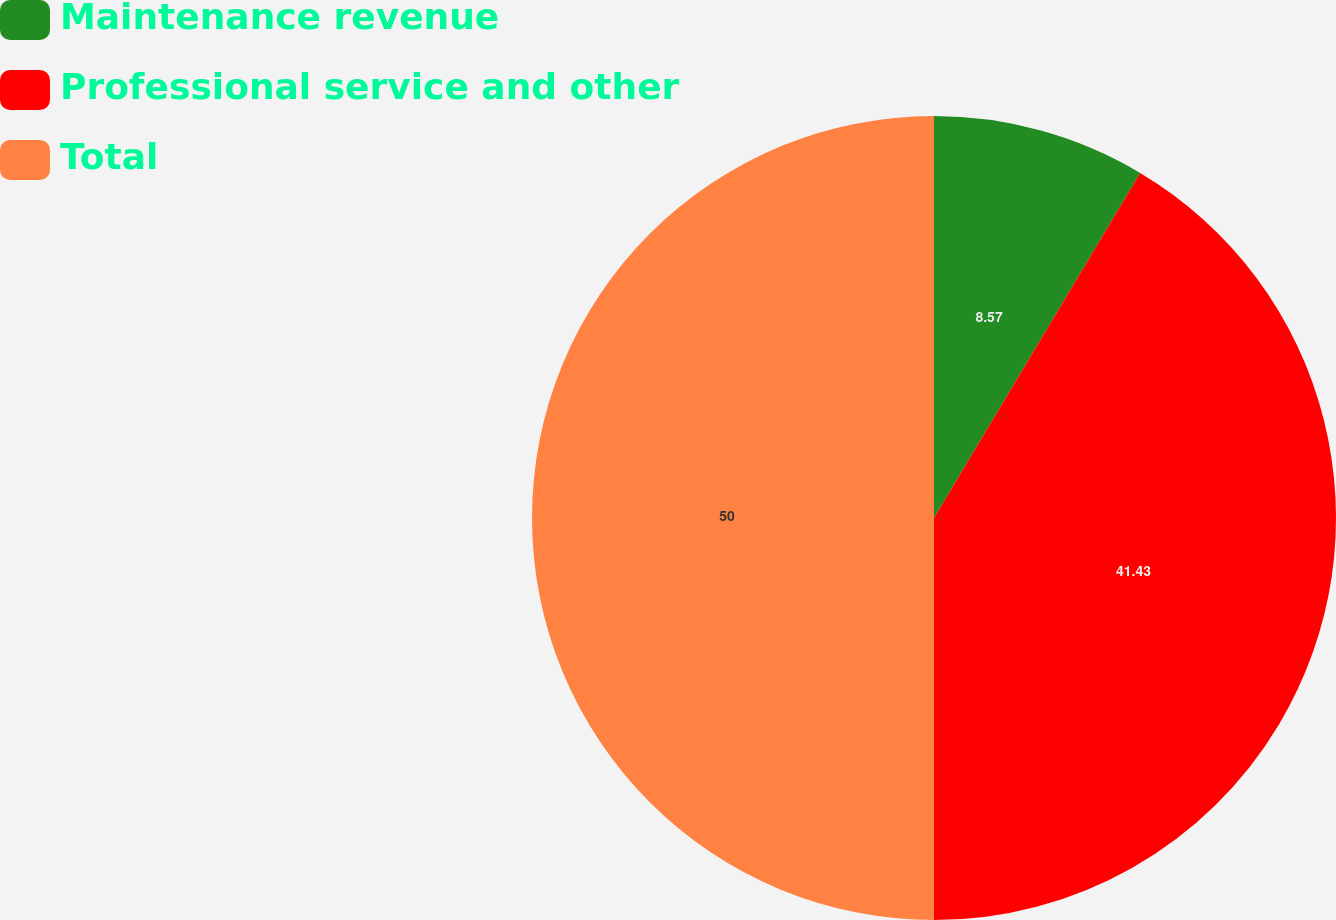<chart> <loc_0><loc_0><loc_500><loc_500><pie_chart><fcel>Maintenance revenue<fcel>Professional service and other<fcel>Total<nl><fcel>8.57%<fcel>41.43%<fcel>50.0%<nl></chart> 